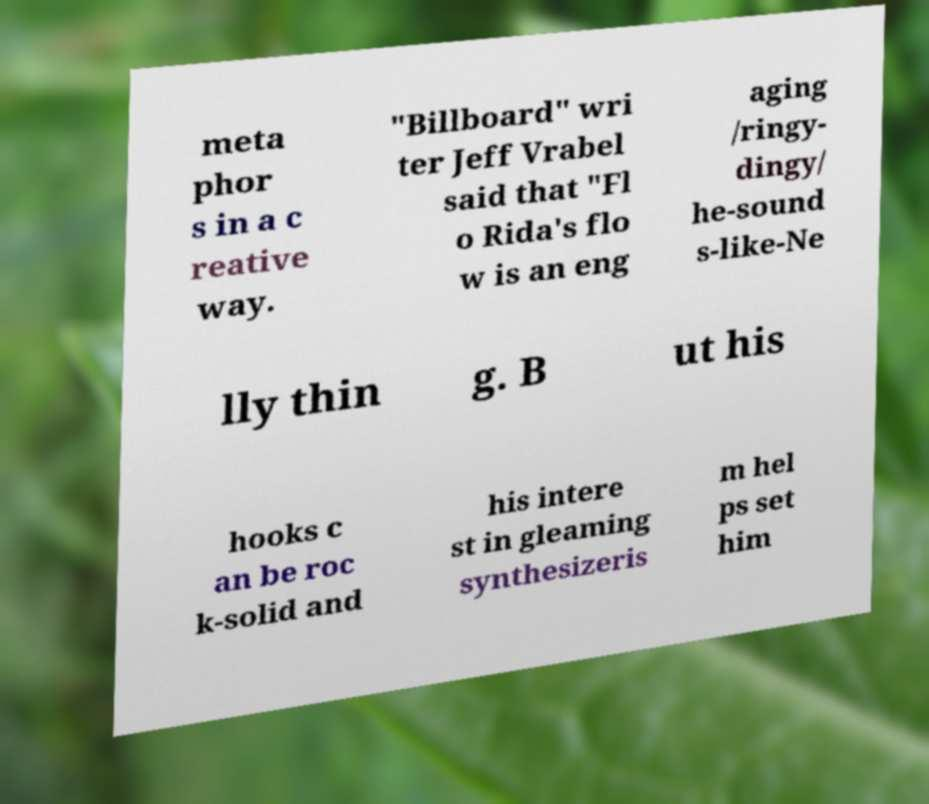Please identify and transcribe the text found in this image. meta phor s in a c reative way. "Billboard" wri ter Jeff Vrabel said that "Fl o Rida's flo w is an eng aging /ringy- dingy/ he-sound s-like-Ne lly thin g. B ut his hooks c an be roc k-solid and his intere st in gleaming synthesizeris m hel ps set him 